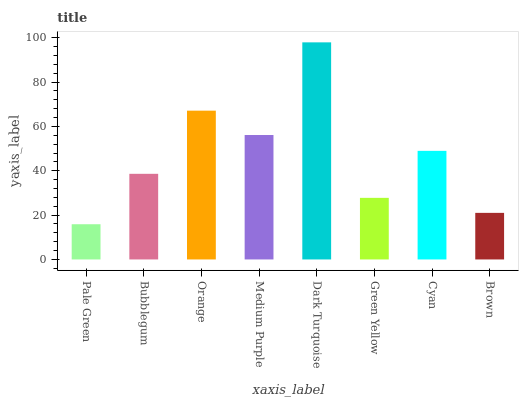Is Pale Green the minimum?
Answer yes or no. Yes. Is Dark Turquoise the maximum?
Answer yes or no. Yes. Is Bubblegum the minimum?
Answer yes or no. No. Is Bubblegum the maximum?
Answer yes or no. No. Is Bubblegum greater than Pale Green?
Answer yes or no. Yes. Is Pale Green less than Bubblegum?
Answer yes or no. Yes. Is Pale Green greater than Bubblegum?
Answer yes or no. No. Is Bubblegum less than Pale Green?
Answer yes or no. No. Is Cyan the high median?
Answer yes or no. Yes. Is Bubblegum the low median?
Answer yes or no. Yes. Is Bubblegum the high median?
Answer yes or no. No. Is Medium Purple the low median?
Answer yes or no. No. 